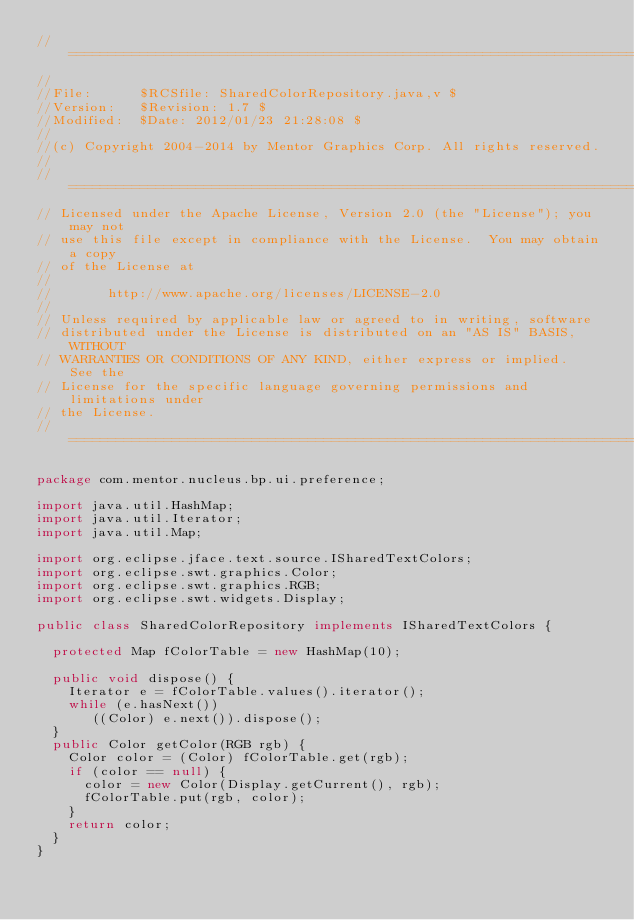Convert code to text. <code><loc_0><loc_0><loc_500><loc_500><_Java_>//========================================================================
//
//File:      $RCSfile: SharedColorRepository.java,v $
//Version:   $Revision: 1.7 $
//Modified:  $Date: 2012/01/23 21:28:08 $
//
//(c) Copyright 2004-2014 by Mentor Graphics Corp. All rights reserved.
//
//========================================================================
// Licensed under the Apache License, Version 2.0 (the "License"); you may not 
// use this file except in compliance with the License.  You may obtain a copy 
// of the License at
//
//       http://www.apache.org/licenses/LICENSE-2.0
//
// Unless required by applicable law or agreed to in writing, software 
// distributed under the License is distributed on an "AS IS" BASIS, WITHOUT 
// WARRANTIES OR CONDITIONS OF ANY KIND, either express or implied.   See the 
// License for the specific language governing permissions and limitations under
// the License.
//========================================================================

package com.mentor.nucleus.bp.ui.preference;

import java.util.HashMap;
import java.util.Iterator;
import java.util.Map;

import org.eclipse.jface.text.source.ISharedTextColors;
import org.eclipse.swt.graphics.Color;
import org.eclipse.swt.graphics.RGB;
import org.eclipse.swt.widgets.Display;

public class SharedColorRepository implements ISharedTextColors {

	protected Map fColorTable = new HashMap(10);

	public void dispose() {
		Iterator e = fColorTable.values().iterator();
		while (e.hasNext())
			 ((Color) e.next()).dispose();
	}
	public Color getColor(RGB rgb) {
		Color color = (Color) fColorTable.get(rgb);
		if (color == null) {
			color = new Color(Display.getCurrent(), rgb);
			fColorTable.put(rgb, color);
		}
		return color;
	}
}
</code> 